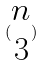<formula> <loc_0><loc_0><loc_500><loc_500>( \begin{matrix} n \\ 3 \end{matrix} )</formula> 